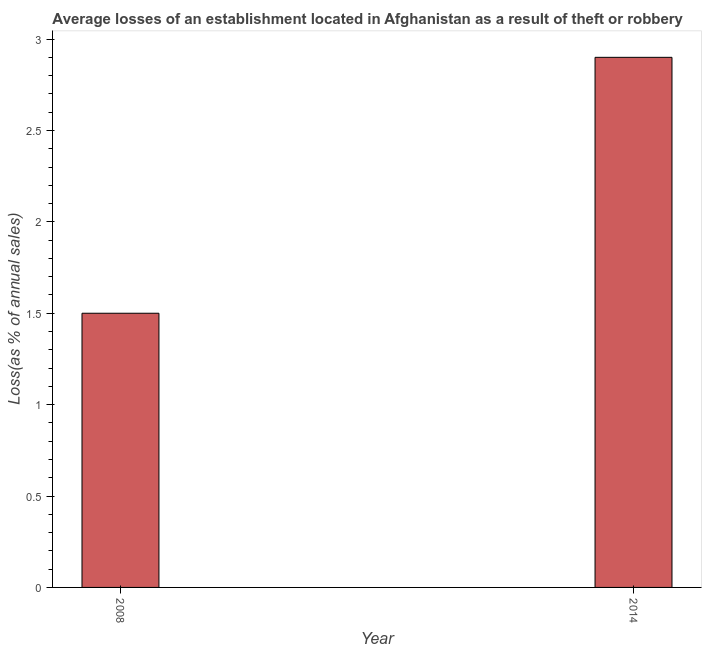Does the graph contain any zero values?
Keep it short and to the point. No. What is the title of the graph?
Your answer should be compact. Average losses of an establishment located in Afghanistan as a result of theft or robbery. What is the label or title of the X-axis?
Your answer should be compact. Year. What is the label or title of the Y-axis?
Keep it short and to the point. Loss(as % of annual sales). What is the losses due to theft in 2014?
Provide a short and direct response. 2.9. Across all years, what is the minimum losses due to theft?
Your answer should be very brief. 1.5. In which year was the losses due to theft maximum?
Your answer should be compact. 2014. In which year was the losses due to theft minimum?
Keep it short and to the point. 2008. What is the sum of the losses due to theft?
Offer a terse response. 4.4. In how many years, is the losses due to theft greater than 1.1 %?
Give a very brief answer. 2. Do a majority of the years between 2014 and 2008 (inclusive) have losses due to theft greater than 2.7 %?
Your answer should be compact. No. What is the ratio of the losses due to theft in 2008 to that in 2014?
Provide a short and direct response. 0.52. Is the losses due to theft in 2008 less than that in 2014?
Your response must be concise. Yes. In how many years, is the losses due to theft greater than the average losses due to theft taken over all years?
Ensure brevity in your answer.  1. How many bars are there?
Offer a terse response. 2. Are the values on the major ticks of Y-axis written in scientific E-notation?
Your answer should be very brief. No. What is the Loss(as % of annual sales) in 2008?
Keep it short and to the point. 1.5. What is the difference between the Loss(as % of annual sales) in 2008 and 2014?
Provide a succinct answer. -1.4. What is the ratio of the Loss(as % of annual sales) in 2008 to that in 2014?
Keep it short and to the point. 0.52. 